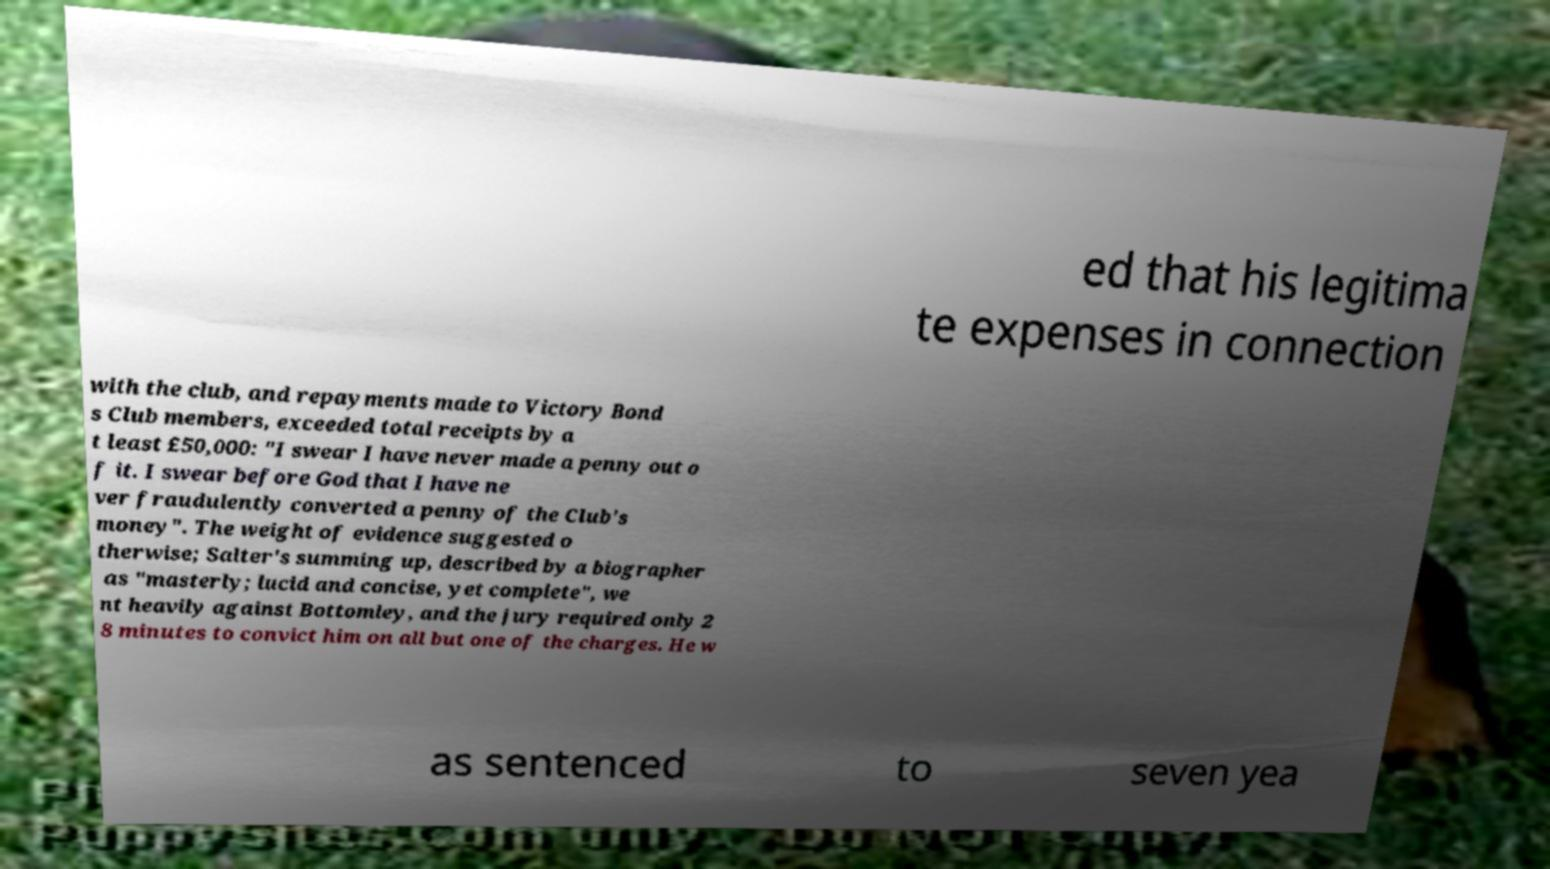Can you read and provide the text displayed in the image?This photo seems to have some interesting text. Can you extract and type it out for me? ed that his legitima te expenses in connection with the club, and repayments made to Victory Bond s Club members, exceeded total receipts by a t least £50,000: "I swear I have never made a penny out o f it. I swear before God that I have ne ver fraudulently converted a penny of the Club's money". The weight of evidence suggested o therwise; Salter's summing up, described by a biographer as "masterly; lucid and concise, yet complete", we nt heavily against Bottomley, and the jury required only 2 8 minutes to convict him on all but one of the charges. He w as sentenced to seven yea 